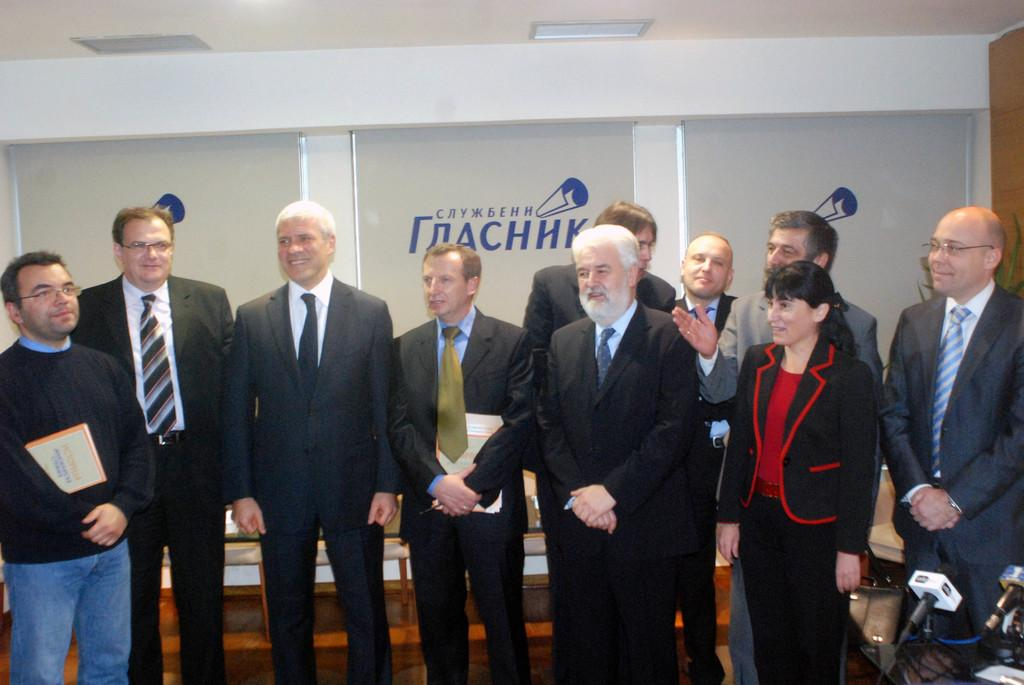How many people are present in the image? There are 10 people in total in the image. Can you describe the arrangement of the people in the image? The people are standing from left to right. What is the person on the left holding? The person on the left is holding a book. What type of badge can be seen on the person on the right? There is no badge visible on any of the people in the image. Can you describe the patch on the person in the middle? There is no patch visible on any of the people in the image. 